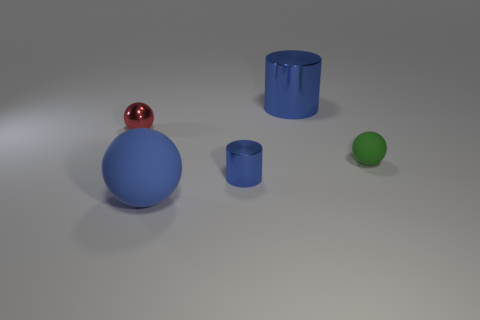How many things are small metal objects in front of the tiny green matte ball or metal cylinders that are in front of the big blue metal thing?
Your answer should be very brief. 1. There is a large metal object that is the same color as the big matte object; what shape is it?
Offer a very short reply. Cylinder. What is the shape of the blue thing that is behind the tiny green rubber object?
Offer a terse response. Cylinder. There is a big object that is in front of the large blue shiny object; is its shape the same as the green rubber object?
Your answer should be compact. Yes. How many objects are either spheres on the right side of the tiny red metallic ball or small cylinders?
Your answer should be compact. 3. There is another tiny metallic thing that is the same shape as the green thing; what color is it?
Give a very brief answer. Red. Is there any other thing of the same color as the small metallic sphere?
Ensure brevity in your answer.  No. There is a cylinder that is in front of the metallic ball; what is its size?
Your answer should be compact. Small. Do the large metallic object and the small shiny object that is on the right side of the red metal object have the same color?
Give a very brief answer. Yes. What number of other things are made of the same material as the big blue cylinder?
Offer a terse response. 2. 